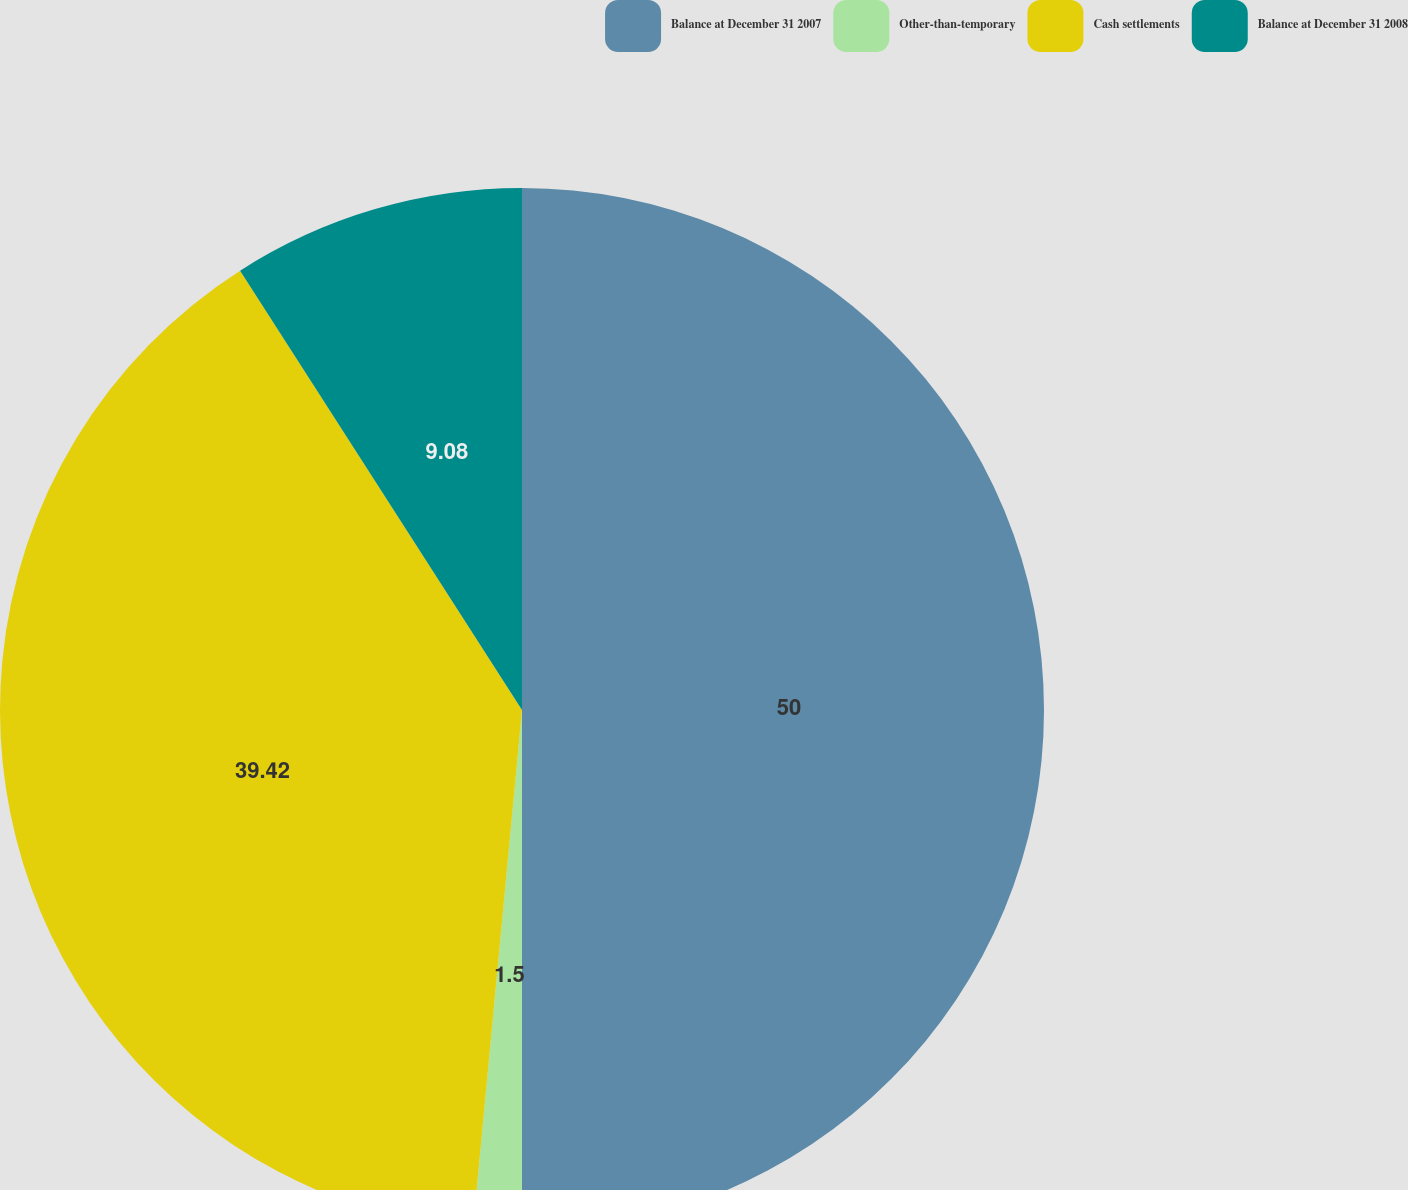Convert chart to OTSL. <chart><loc_0><loc_0><loc_500><loc_500><pie_chart><fcel>Balance at December 31 2007<fcel>Other-than-temporary<fcel>Cash settlements<fcel>Balance at December 31 2008<nl><fcel>50.0%<fcel>1.5%<fcel>39.42%<fcel>9.08%<nl></chart> 